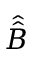<formula> <loc_0><loc_0><loc_500><loc_500>\hat { \hat { B } }</formula> 